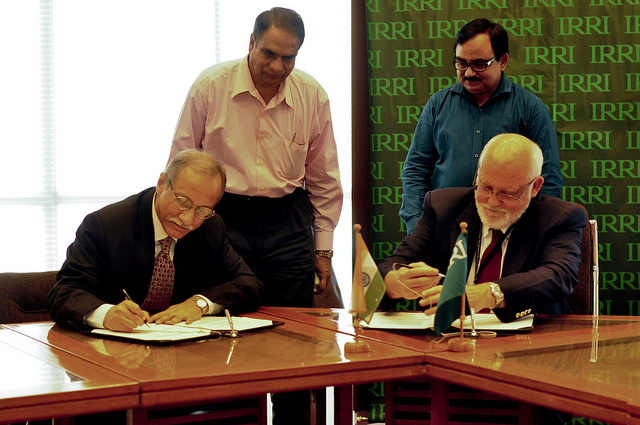Tell me about the people observing the signing. There are two individuals standing behind the signatories. They are dressed in business attire, suggesting they might be witnesses, colleagues, or officials overseeing the signing process. Do they seem to be part of the event? Yes, their attentive posture and focus on the activity at the table imply they are actively involved in the proceedings, possibly ensuring that the event runs smoothly. 